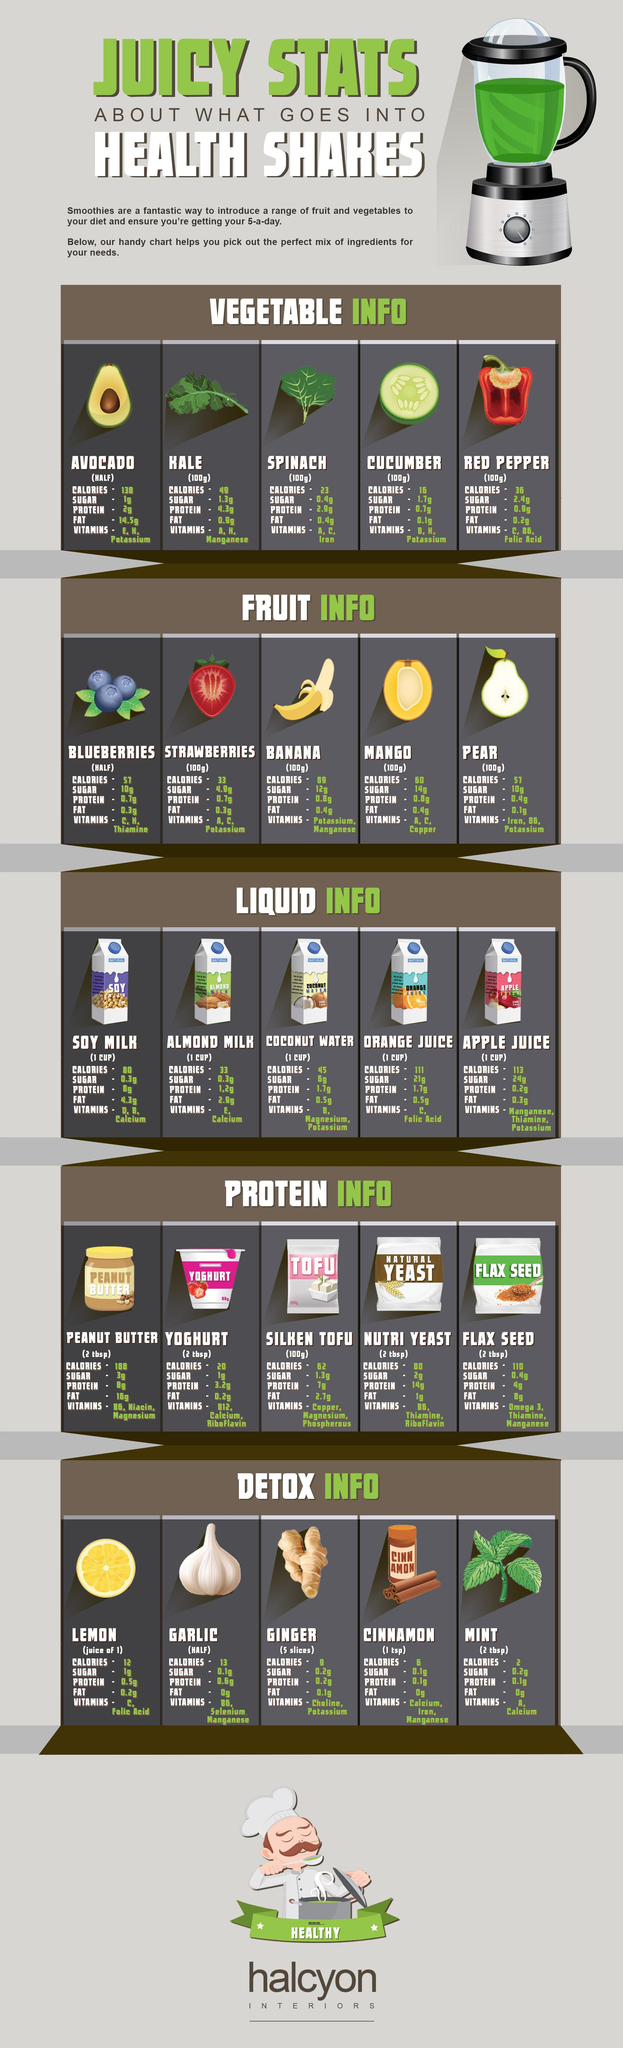what is the quantity considered for silken tofu
Answer the question with a short phrase. 100 gm which has the second least calories in protein silken tofu which liquid has less fat than soy milk? apple juice what are the vitamins in garlic B6, Selenium Manganese what is the sum of fat for kale and spinach 1.3 what is the quantity considered for cinnamon 1 tsp what carries the highest calories in fruits banana what is the vitamin in strawberries A, C, Potassium what is the colour of the mixture inside the grinder, green, white? green 